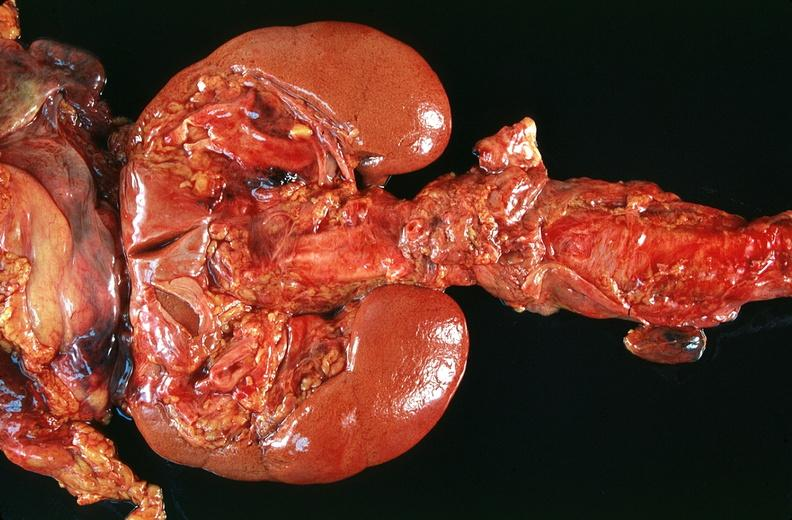where is this?
Answer the question using a single word or phrase. Urinary 